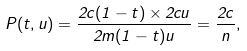Convert formula to latex. <formula><loc_0><loc_0><loc_500><loc_500>P ( t , u ) = \frac { 2 c ( 1 - t ) \times 2 c u } { 2 m ( 1 - t ) u } = \frac { 2 c } { n } ,</formula> 